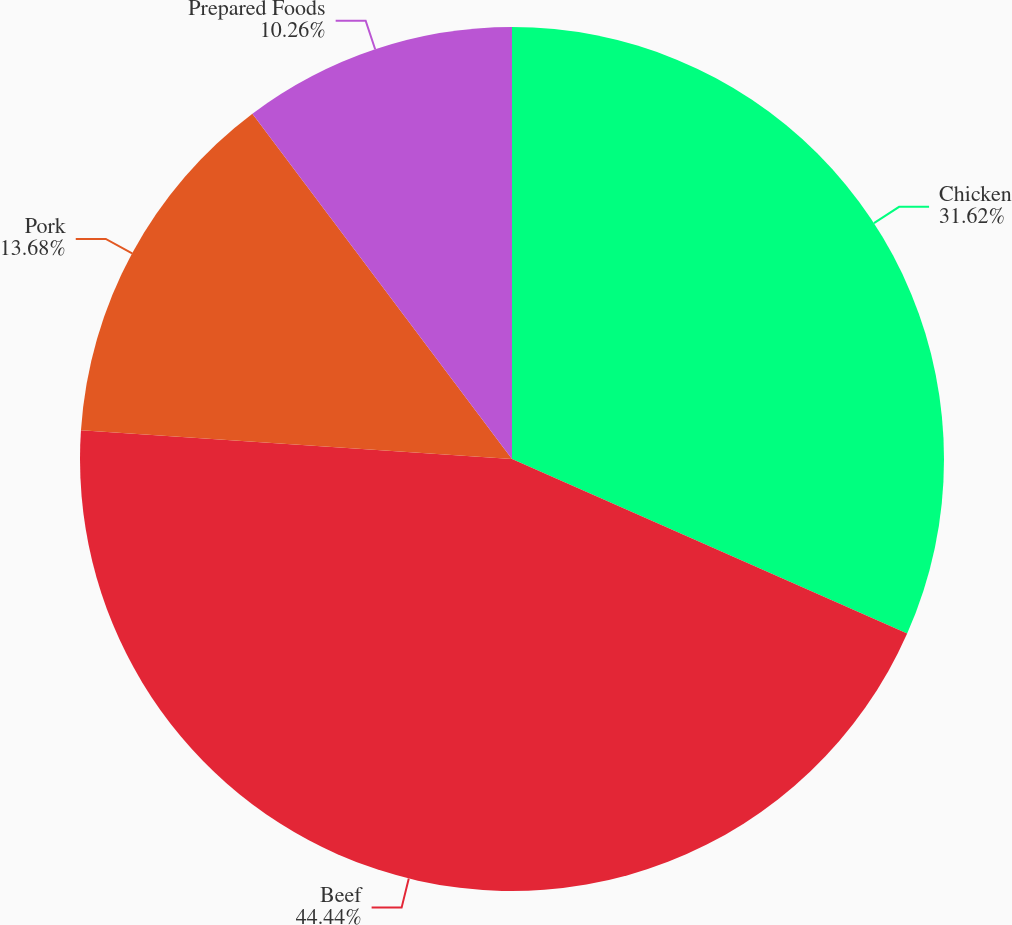<chart> <loc_0><loc_0><loc_500><loc_500><pie_chart><fcel>Chicken<fcel>Beef<fcel>Pork<fcel>Prepared Foods<nl><fcel>31.62%<fcel>44.44%<fcel>13.68%<fcel>10.26%<nl></chart> 